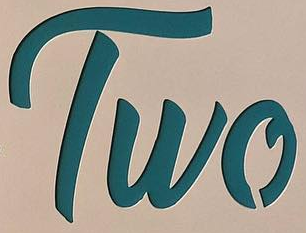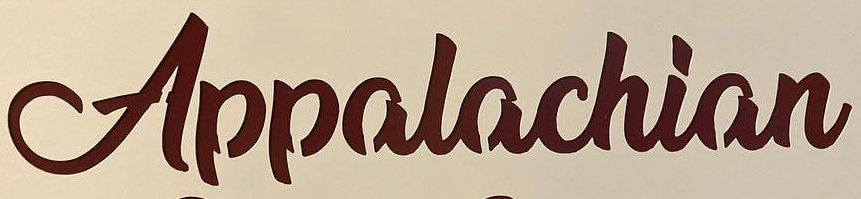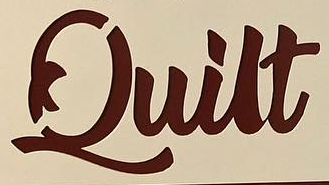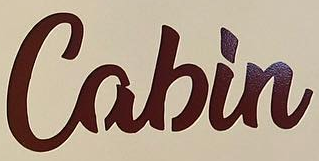What words can you see in these images in sequence, separated by a semicolon? Two; Appalachian; Quilt; Cabin 